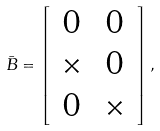Convert formula to latex. <formula><loc_0><loc_0><loc_500><loc_500>\bar { B } = \left [ \begin{array} { c c } 0 & 0 \\ \times & 0 \\ 0 & \times \end{array} \right ] ,</formula> 